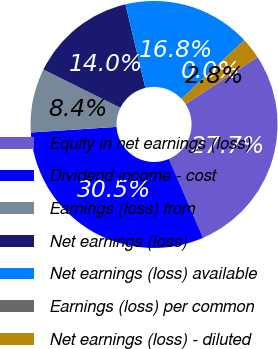Convert chart to OTSL. <chart><loc_0><loc_0><loc_500><loc_500><pie_chart><fcel>Equity in net earnings (loss)<fcel>Dividend income - cost<fcel>Earnings (loss) from<fcel>Net earnings (loss)<fcel>Net earnings (loss) available<fcel>Earnings (loss) per common<fcel>Net earnings (loss) - diluted<nl><fcel>27.67%<fcel>30.46%<fcel>8.37%<fcel>13.95%<fcel>16.75%<fcel>0.0%<fcel>2.79%<nl></chart> 